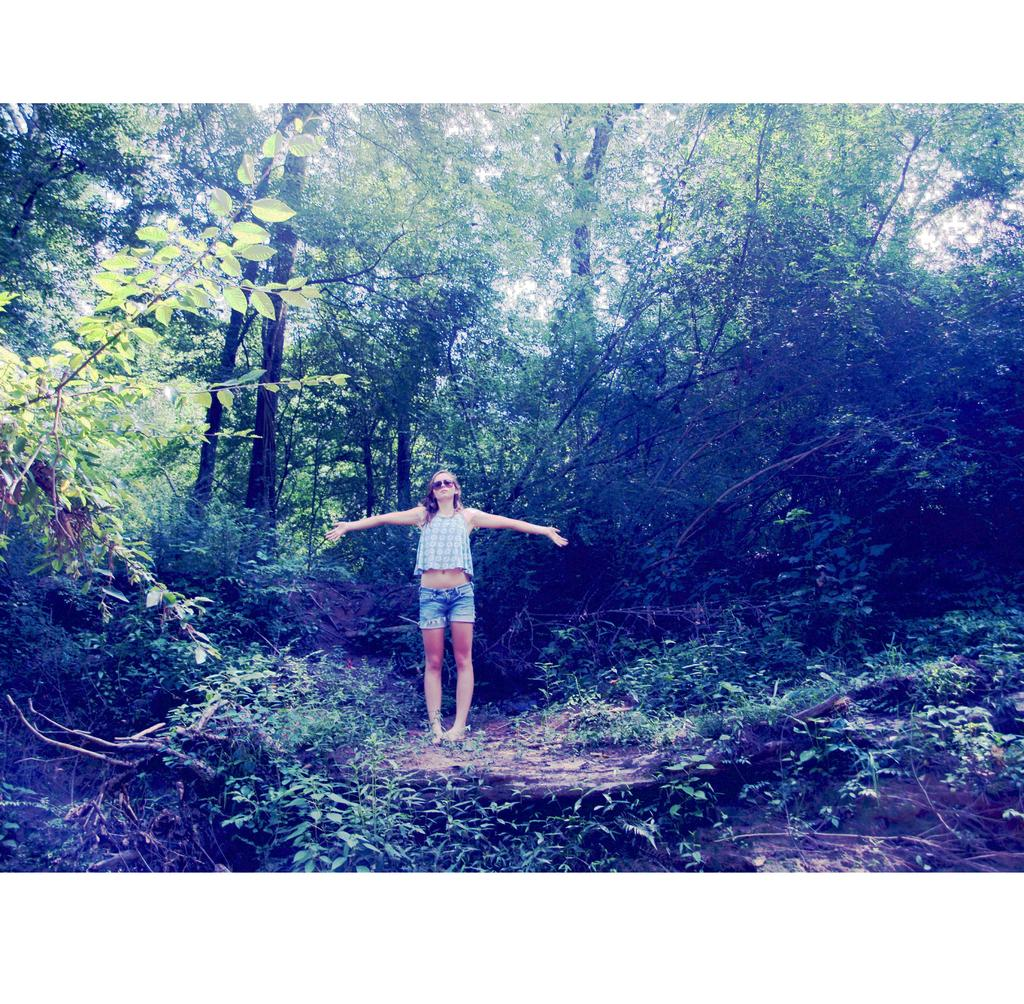What is the main subject of the image? There is a woman standing in the image. What is the woman wearing on her face? The woman is wearing goggles. What type of vegetation can be seen towards the top of the image? There are trees towards the top of the image. What type of vegetation can be seen towards the bottom of the image? There are plants towards the bottom of the image. What letters are visible on the woman's shirt in the image? There is no information provided about any letters on the woman's shirt, so we cannot determine if any are visible. 